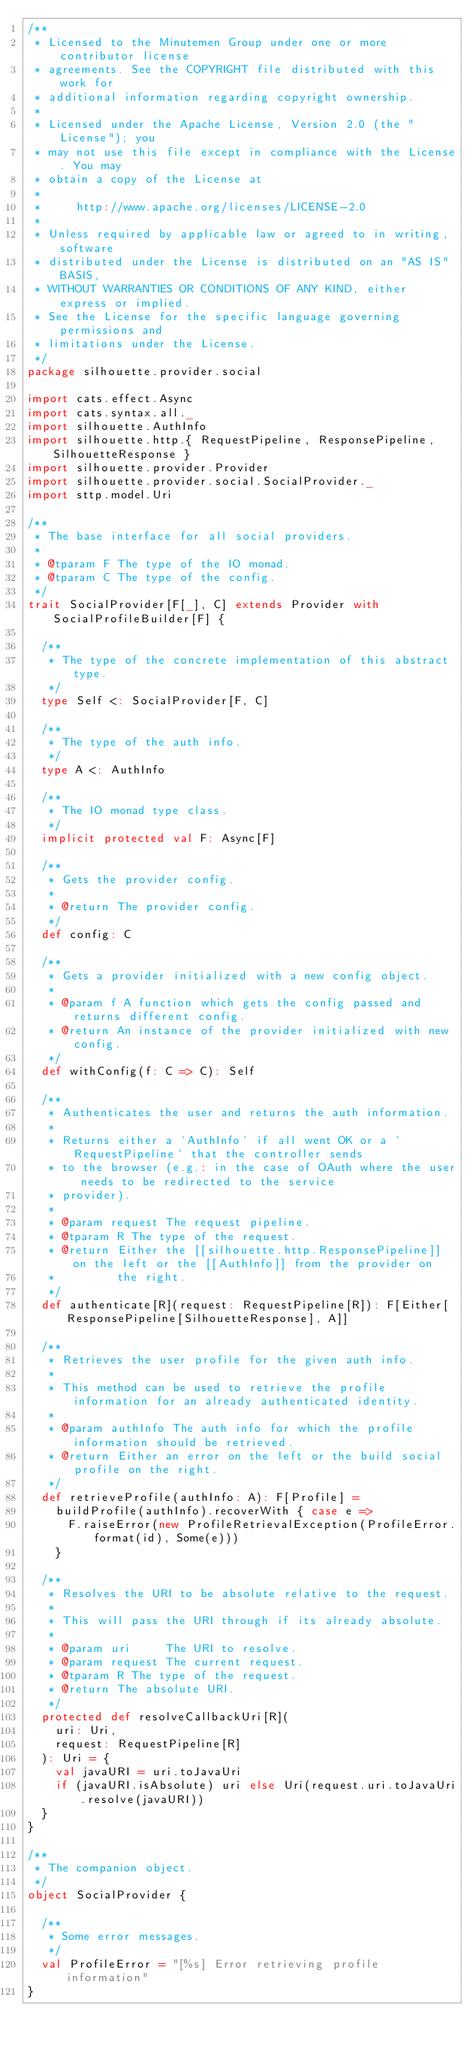<code> <loc_0><loc_0><loc_500><loc_500><_Scala_>/**
 * Licensed to the Minutemen Group under one or more contributor license
 * agreements. See the COPYRIGHT file distributed with this work for
 * additional information regarding copyright ownership.
 *
 * Licensed under the Apache License, Version 2.0 (the "License"); you
 * may not use this file except in compliance with the License. You may
 * obtain a copy of the License at
 *
 *     http://www.apache.org/licenses/LICENSE-2.0
 *
 * Unless required by applicable law or agreed to in writing, software
 * distributed under the License is distributed on an "AS IS" BASIS,
 * WITHOUT WARRANTIES OR CONDITIONS OF ANY KIND, either express or implied.
 * See the License for the specific language governing permissions and
 * limitations under the License.
 */
package silhouette.provider.social

import cats.effect.Async
import cats.syntax.all._
import silhouette.AuthInfo
import silhouette.http.{ RequestPipeline, ResponsePipeline, SilhouetteResponse }
import silhouette.provider.Provider
import silhouette.provider.social.SocialProvider._
import sttp.model.Uri

/**
 * The base interface for all social providers.
 *
 * @tparam F The type of the IO monad.
 * @tparam C The type of the config.
 */
trait SocialProvider[F[_], C] extends Provider with SocialProfileBuilder[F] {

  /**
   * The type of the concrete implementation of this abstract type.
   */
  type Self <: SocialProvider[F, C]

  /**
   * The type of the auth info.
   */
  type A <: AuthInfo

  /**
   * The IO monad type class.
   */
  implicit protected val F: Async[F]

  /**
   * Gets the provider config.
   *
   * @return The provider config.
   */
  def config: C

  /**
   * Gets a provider initialized with a new config object.
   *
   * @param f A function which gets the config passed and returns different config.
   * @return An instance of the provider initialized with new config.
   */
  def withConfig(f: C => C): Self

  /**
   * Authenticates the user and returns the auth information.
   *
   * Returns either a `AuthInfo` if all went OK or a `RequestPipeline` that the controller sends
   * to the browser (e.g.: in the case of OAuth where the user needs to be redirected to the service
   * provider).
   *
   * @param request The request pipeline.
   * @tparam R The type of the request.
   * @return Either the [[silhouette.http.ResponsePipeline]] on the left or the [[AuthInfo]] from the provider on
   *         the right.
   */
  def authenticate[R](request: RequestPipeline[R]): F[Either[ResponsePipeline[SilhouetteResponse], A]]

  /**
   * Retrieves the user profile for the given auth info.
   *
   * This method can be used to retrieve the profile information for an already authenticated identity.
   *
   * @param authInfo The auth info for which the profile information should be retrieved.
   * @return Either an error on the left or the build social profile on the right.
   */
  def retrieveProfile(authInfo: A): F[Profile] =
    buildProfile(authInfo).recoverWith { case e =>
      F.raiseError(new ProfileRetrievalException(ProfileError.format(id), Some(e)))
    }

  /**
   * Resolves the URI to be absolute relative to the request.
   *
   * This will pass the URI through if its already absolute.
   *
   * @param uri     The URI to resolve.
   * @param request The current request.
   * @tparam R The type of the request.
   * @return The absolute URI.
   */
  protected def resolveCallbackUri[R](
    uri: Uri,
    request: RequestPipeline[R]
  ): Uri = {
    val javaURI = uri.toJavaUri
    if (javaURI.isAbsolute) uri else Uri(request.uri.toJavaUri.resolve(javaURI))
  }
}

/**
 * The companion object.
 */
object SocialProvider {

  /**
   * Some error messages.
   */
  val ProfileError = "[%s] Error retrieving profile information"
}
</code> 